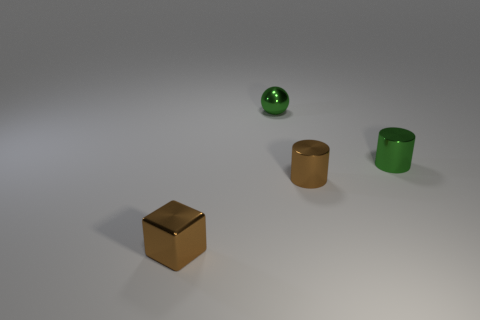Add 3 gray matte cubes. How many objects exist? 7 Subtract all cubes. How many objects are left? 3 Subtract all tiny cyan cylinders. Subtract all tiny green metallic things. How many objects are left? 2 Add 3 cylinders. How many cylinders are left? 5 Add 4 metallic cylinders. How many metallic cylinders exist? 6 Subtract 1 brown blocks. How many objects are left? 3 